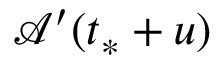<formula> <loc_0><loc_0><loc_500><loc_500>\mathcal { A } ^ { \prime } ( t _ { * } + u )</formula> 